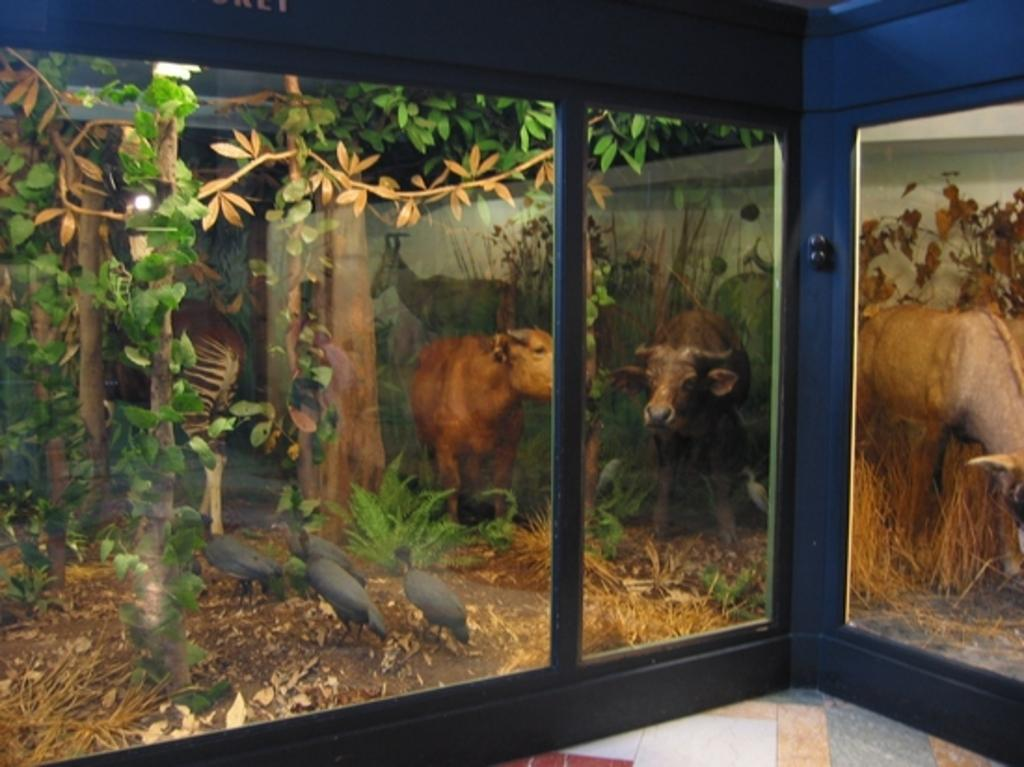What type of walls are present in the image? The image contains glass walls. What can be found inside the glass walls? There are dolls of plants, animals, and birds inside the glass walls. What type of drug can be seen in the image? There is no drug present in the image; it features dolls of plants, animals, and birds inside glass walls. 